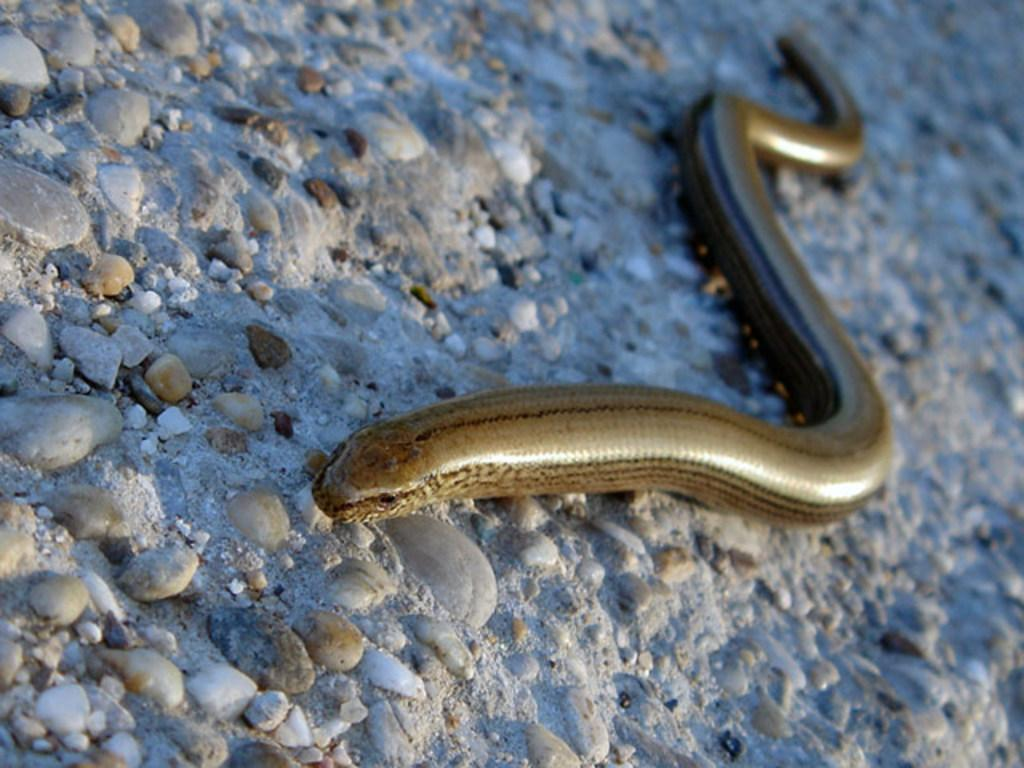What animal is present in the image? There is a snake in the image. What is the snake doing in the image? The snake is moving on stones. What type of quilt is being offered to the snake in the image? There is no quilt present in the image, and the snake is not being offered anything. 